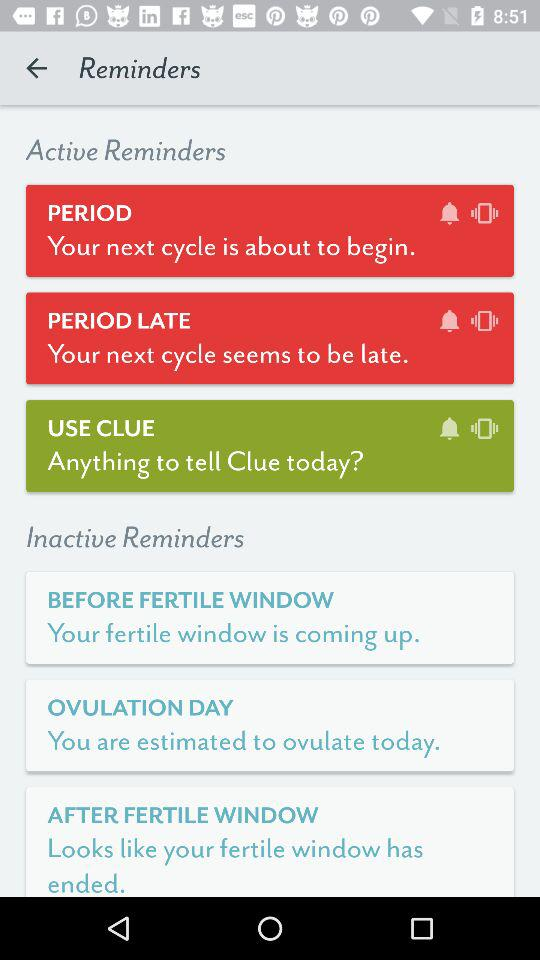What are the inactive reminders? The inactive reminders are "BEFORE FERTILE WINDOW", "OVULATION DAY" and "AFTER FERTILE WINDOW". 